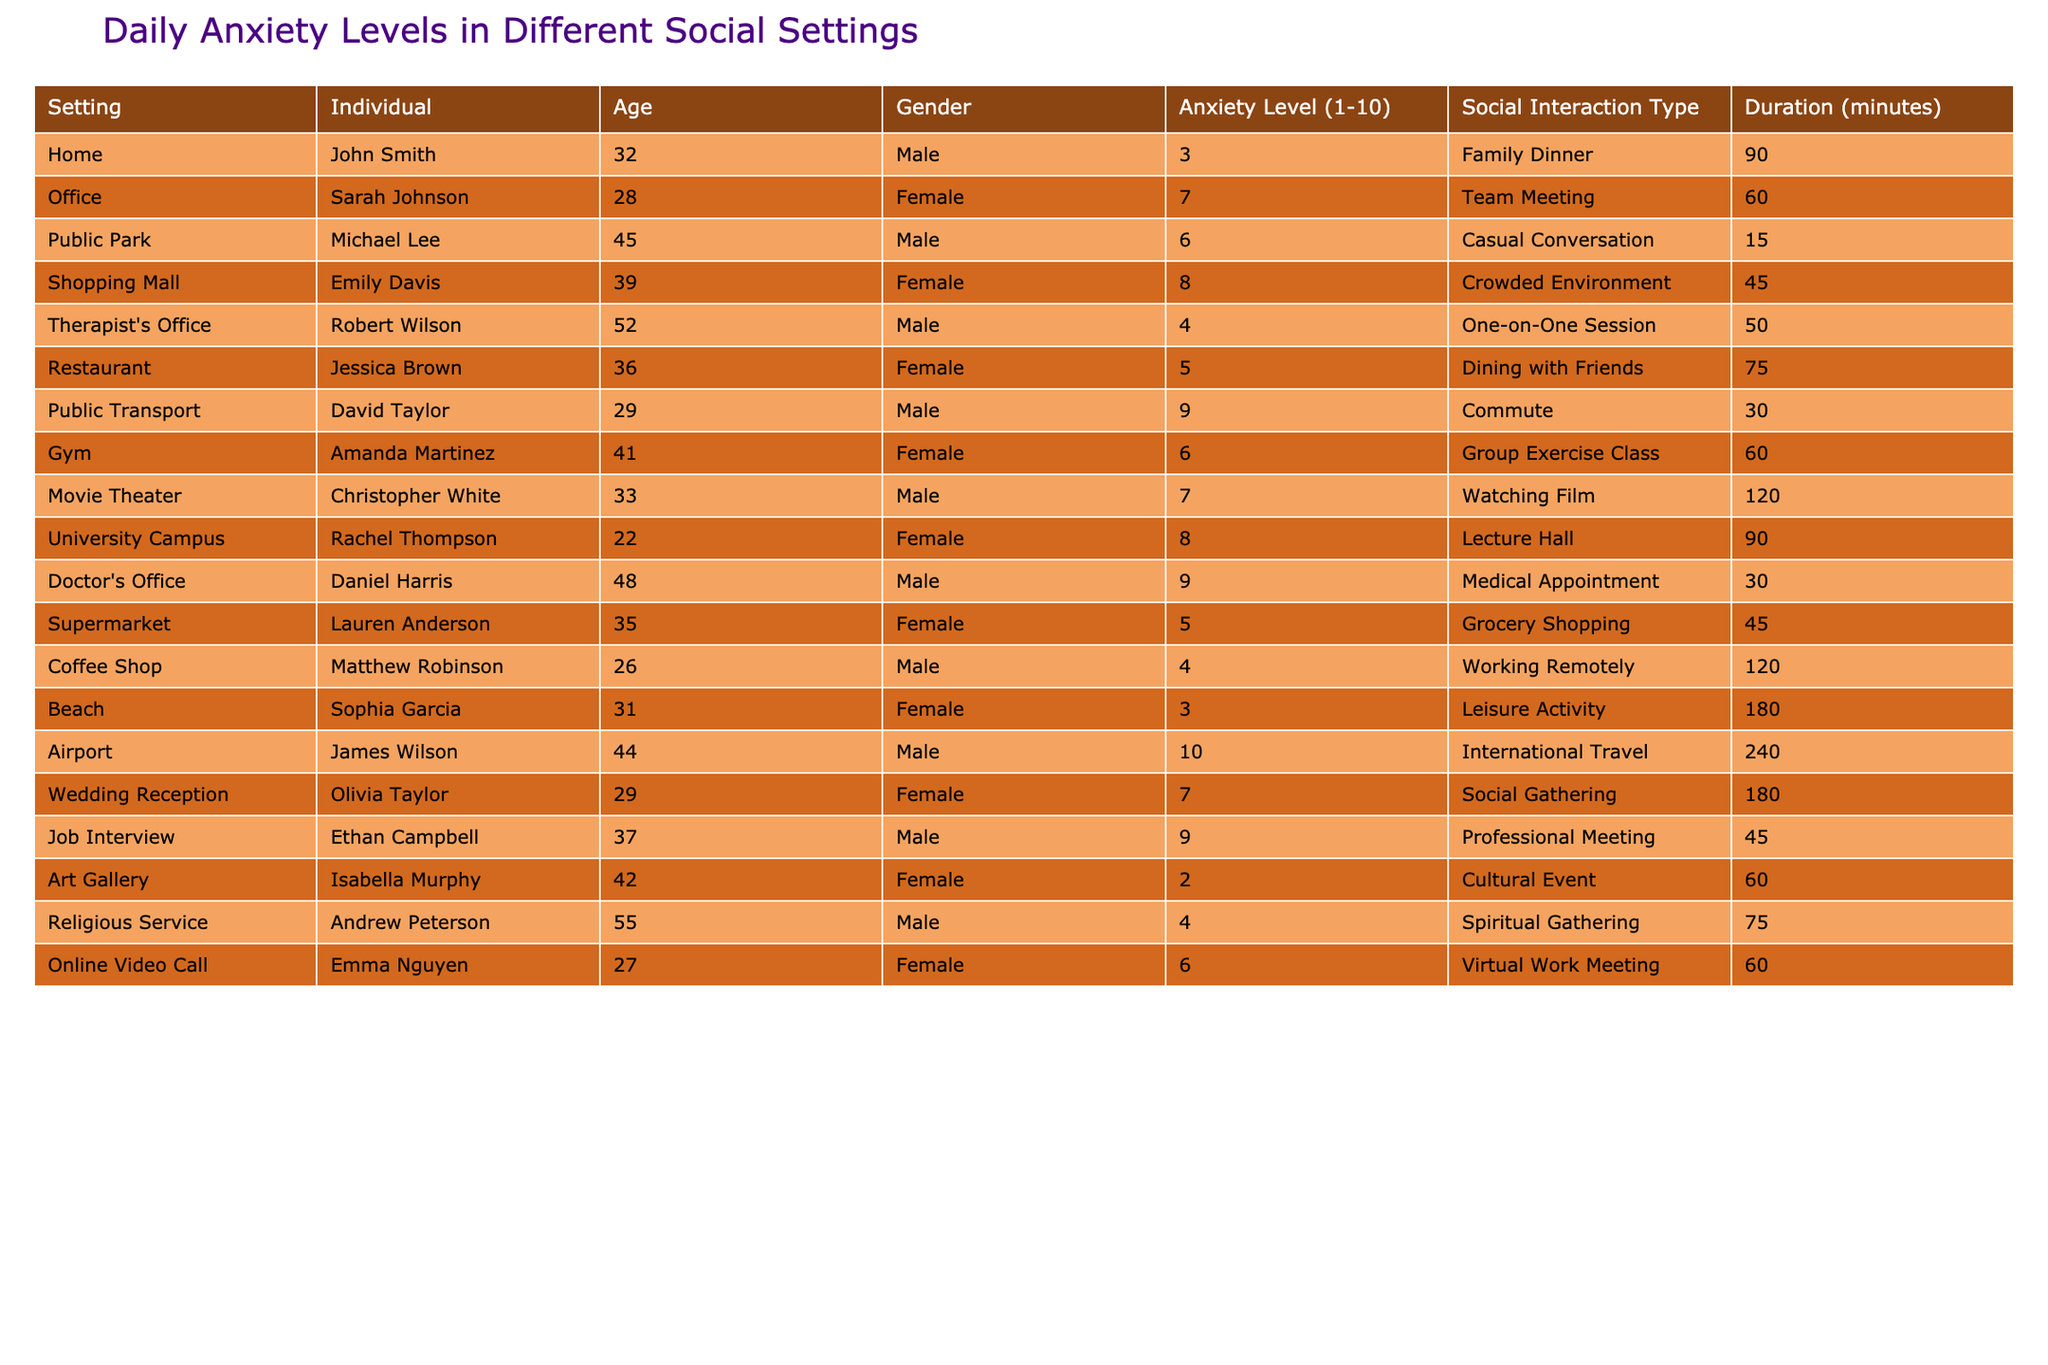What is the highest anxiety level recorded in the table? The highest anxiety level is found in the row for James Wilson at the Airport setting, where it is recorded as 10.
Answer: 10 Who had the lowest anxiety level and in which setting? The lowest anxiety level is 2, recorded by Isabella Murphy at the Art Gallery.
Answer: Isabella Murphy, Art Gallery What is the average anxiety level for individuals in public transport settings? There is only one individual, David Taylor, with an anxiety level of 9 in the Public Transport setting, making the average also 9.
Answer: 9 Did Sarah Johnson experience higher anxiety than Jessica Brown? Sarah Johnson's anxiety level is 7, while Jessica Brown's is 5, so yes, Sarah Johnson experienced higher anxiety.
Answer: Yes What is the total duration of social interactions for individuals with an anxiety level of 6? The individuals with an anxiety level of 6 are Michael Lee (15 minutes), Amanda Martinez (60 minutes), and Emma Nguyen (60 minutes). The total duration is 15 + 60 + 60 = 135 minutes.
Answer: 135 minutes How many females had an anxiety level of 8 or higher? The females with an anxiety level of 8 or higher are Emily Davis, University Campus (8), and Jessica Brown (5). Thus, there are two females with an anxiety level of 8 or higher.
Answer: 2 What percentage of the individuals experiencing an anxiety level of 9 were in a professional or medical setting? There are two individuals (David Taylor and Daniel Harris) with an anxiety level of 9; both are in professional (Job Interview) and medical (Doctor's Office) settings. Thus, 100% were in such settings.
Answer: 100% What is the difference in anxiety levels between the youngest and the oldest individuals in the table? The youngest was Rachel Thompson at age 22 with an anxiety level of 8 and the oldest was Andrew Peterson at age 55 with an anxiety level of 4. The difference in their anxiety levels is 8 - 4 = 4.
Answer: 4 What setting had the longest duration of social interaction with an anxiety level above 6? The Airport had the longest duration (240 minutes) with the highest anxiety level (10).
Answer: Airport Are there more males or females in the table? Counting reveals that there are 7 males (John, Michael, Robert, David, Christopher, Daniel, Andrew) and 7 females (Sarah, Emily, Jessica, Amanda, Rachel, Olivia, Emma), thus the numbers are equal.
Answer: Equal 